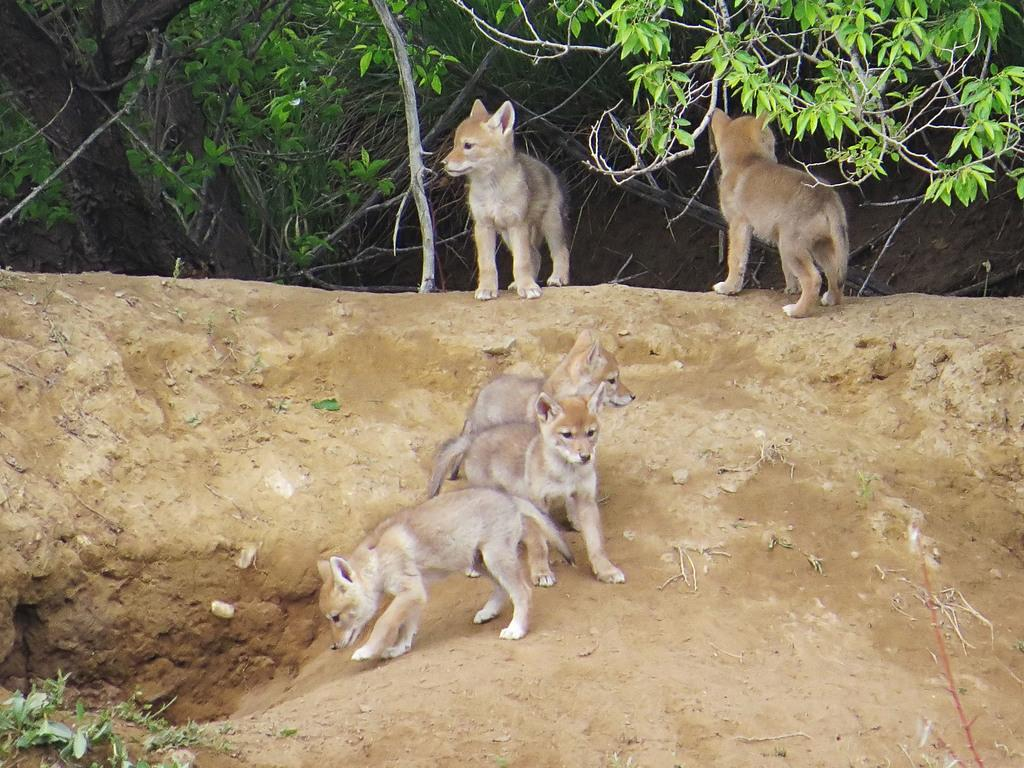What type of living organisms can be seen on the ground in the image? There are animals on the ground in the image. What other elements can be seen in the image besides the animals? There are plants in the image. What type of authority figure can be seen in the image? There is no authority figure present in the image. What type of food can be seen being prepared in the image? There is no food preparation visible in the image. 